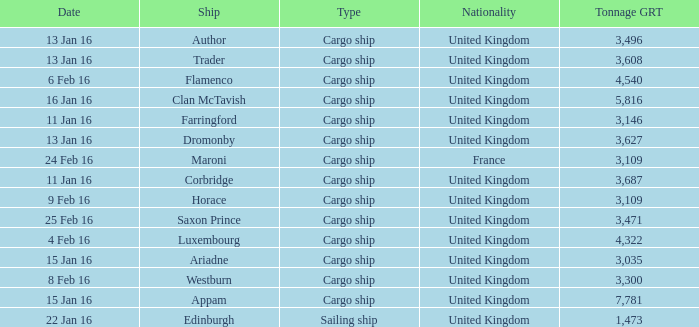What is the tonnage grt of the ship author? 3496.0. 